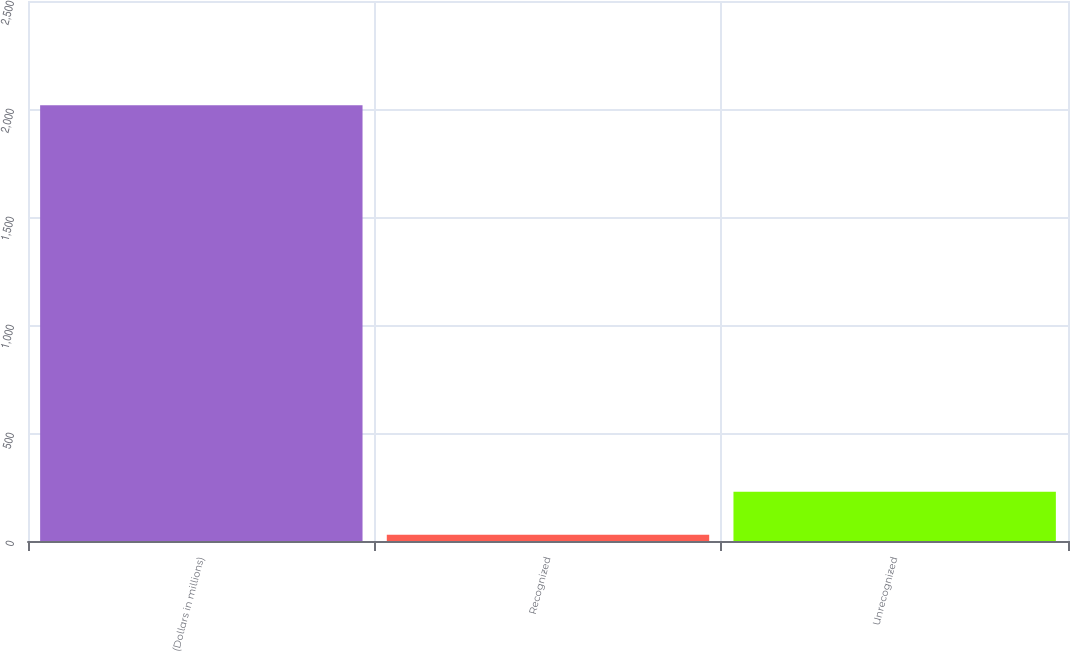<chart> <loc_0><loc_0><loc_500><loc_500><bar_chart><fcel>(Dollars in millions)<fcel>Recognized<fcel>Unrecognized<nl><fcel>2017<fcel>29<fcel>227.8<nl></chart> 